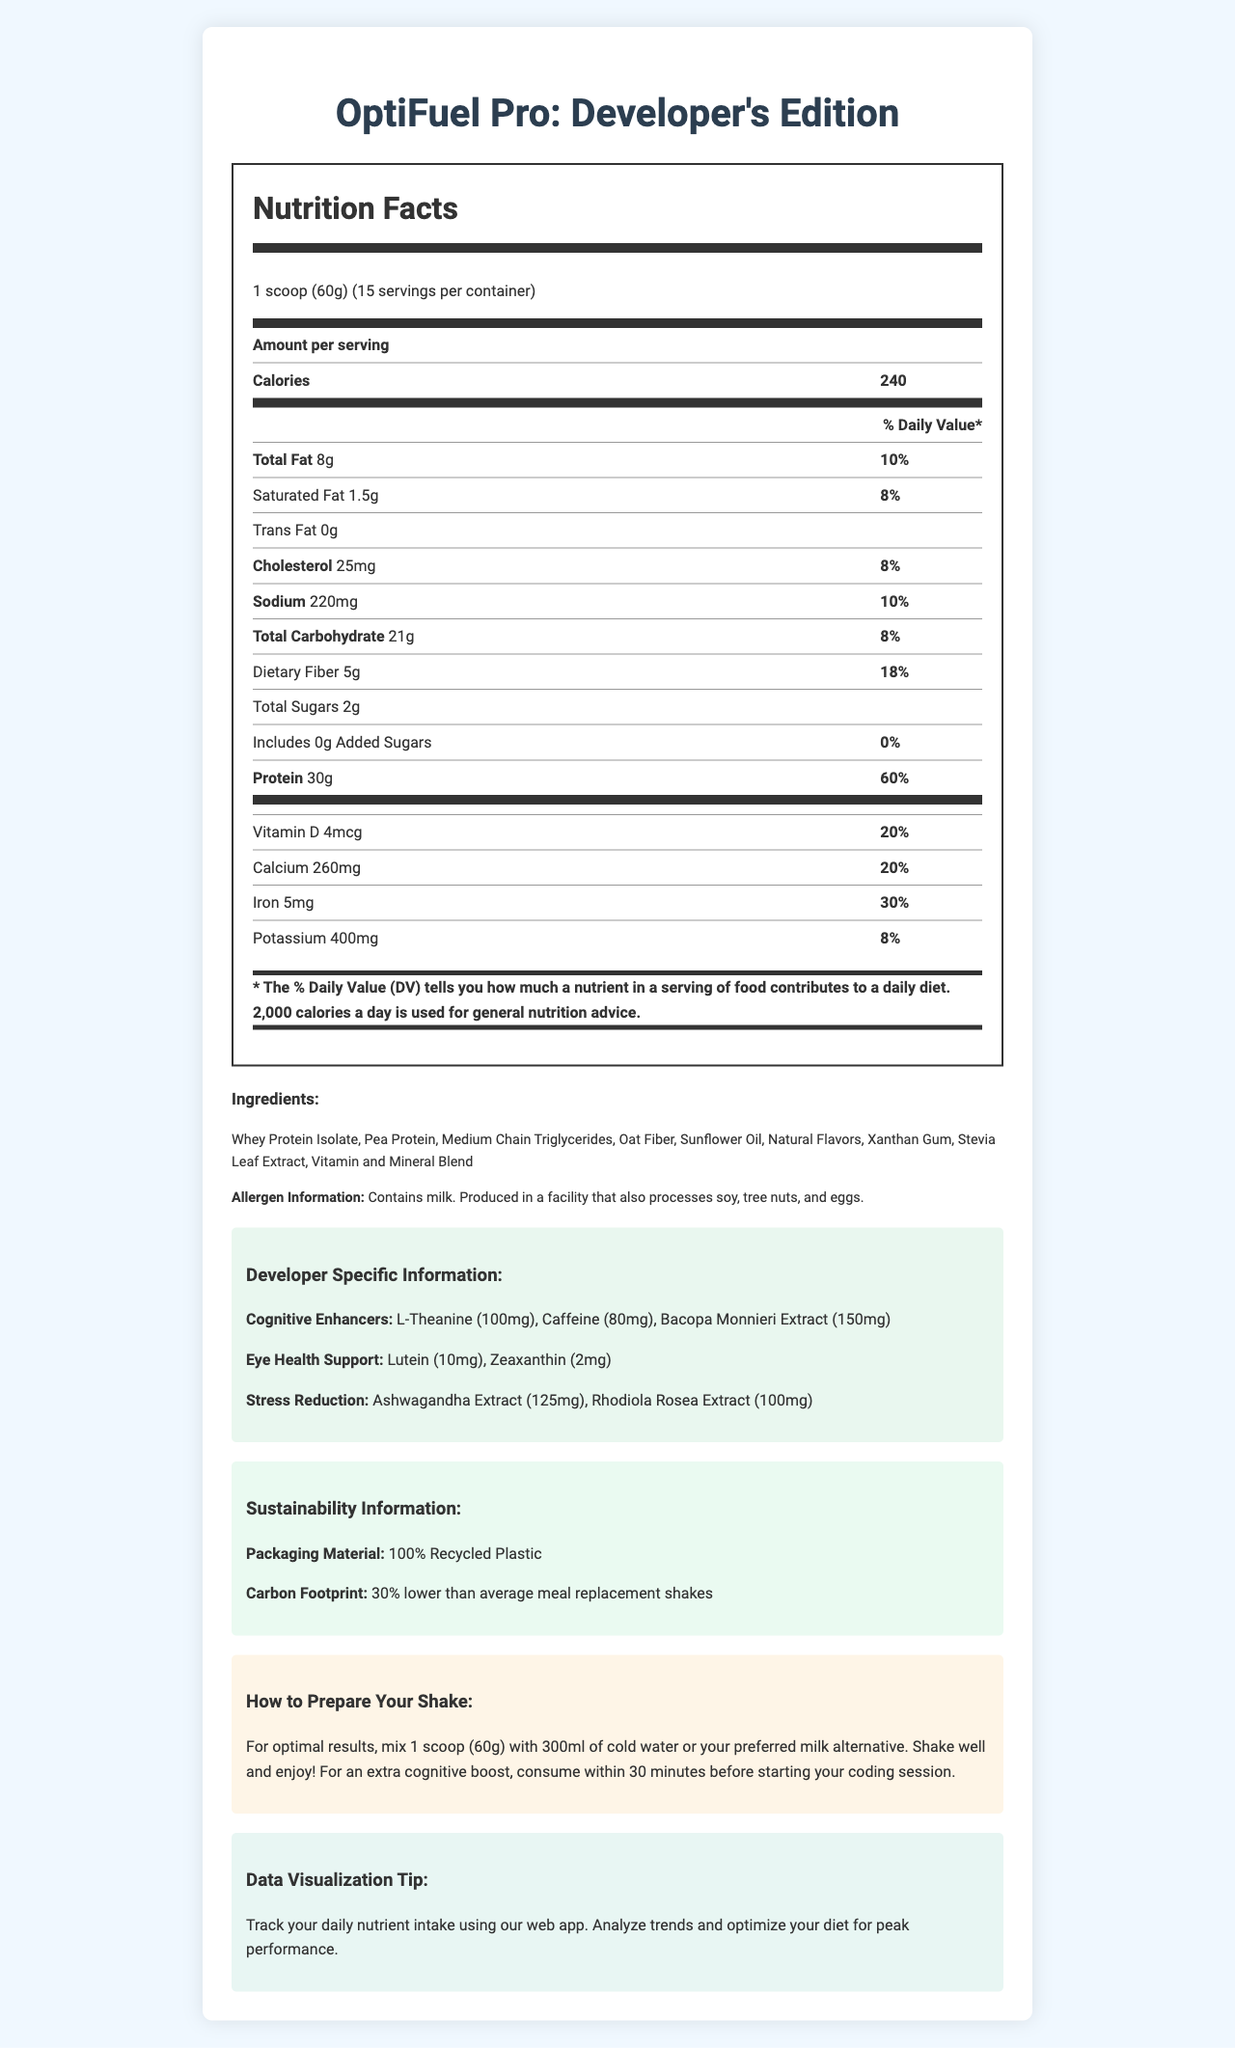what is the serving size? The serving size is clearly stated in the document under the Nutrition Facts section as "1 scoop (60g)".
Answer: 1 scoop (60g) how many servings are there per container? According to the document, there are 15 servings per container.
Answer: 15 how many calories does one serving contain? The document lists that one serving contains 240 calories.
Answer: 240 list the sub-categories of fats and their amounts The sub-categories and their amounts are mentioned under the 'Total Fat' section of the Nutrition Facts.
Answer: Saturated Fat: 1.5g, Trans Fat: 0g, Polyunsaturated Fat: 3g, Monounsaturated Fat: 3.5g how much cholesterol is in one serving? The Nutritional Facts section under 'Cholesterol' indicates that there is 25mg of cholesterol per serving.
Answer: 25mg what percentage of the daily value is provided by the protein content in one serving? The document shows that one serving provides 60% of the daily value of protein.
Answer: 60% how much dietary fiber is in one serving? Under the 'Total Carbohydrate' section, the document specifies that there is 5g of dietary fiber per serving.
Answer: 5g what are the ingredients listed for this product? The ingredients are listed in the Ingredients section of the document.
Answer: Whey Protein Isolate, Pea Protein, Medium Chain Triglycerides, Oat Fiber, Sunflower Oil, Natural Flavors, Xanthan Gum, Stevia Leaf Extract, Vitamin and Mineral Blend What allergens does this product contain? This information is mentioned in the Allergen Information section.
Answer: Contains milk. Produced in a facility that also processes soy, tree nuts, and eggs. what is the recommended preparation method for this shake? The preparation method is detailed in the 'How to Prepare Your Shake' section.
Answer: Mix 1 scoop (60g) with 300ml of cold water or milk alternative, shake well and consume within 30 minutes before coding session. which vitamin has the highest daily value percentage per serving? A. Vitamin D B. Calcium C. Vitamin B12 D. Iron The document indicates that Vitamin B12 has the highest daily value percentage at 100%.
Answer: C. Vitamin B12 which cognitive enhancer is included in the highest quantity? I. L-Theanine II. Caffeine III. Bacopa Monnieri Extract Bacopa Monnieri Extract is listed as 150mg, L-Theanine is 100mg, and Caffeine is 80mg.
Answer: III. Bacopa Monnieri Extract does this product contain added sugars? According to the 'Total Sugars' sub-category, the document states 'Includes 0g Added Sugars'.
Answer: No is the packaging material sustainable? The Sustainability Information section mentions that the packaging material is 100% recycled plastic.
Answer: Yes Please describe the main idea of this document briefly. The document provides comprehensive details about the nutritional content, ingredients, and specific benefits tailored for developers including cognitive enhancers, stress reduction components, and preparation instructions.
Answer: The document is a detailed nutrition facts label for "OptiFuel Pro: Developer's Edition," a protein-rich meal replacement shake. It includes nutritional information, ingredients, allergens, developer-centric cognitive enhancers, sustainability info, and preparation instructions. is this product suitable for a vegan diet? The product contains Whey Protein Isolate, which is derived from milk, making it unsuitable for vegans. However, the document doesn't explicitly address vegan suitability, so a definitive answer cannot be determined solely from the visible information.
Answer: Cannot be determined 